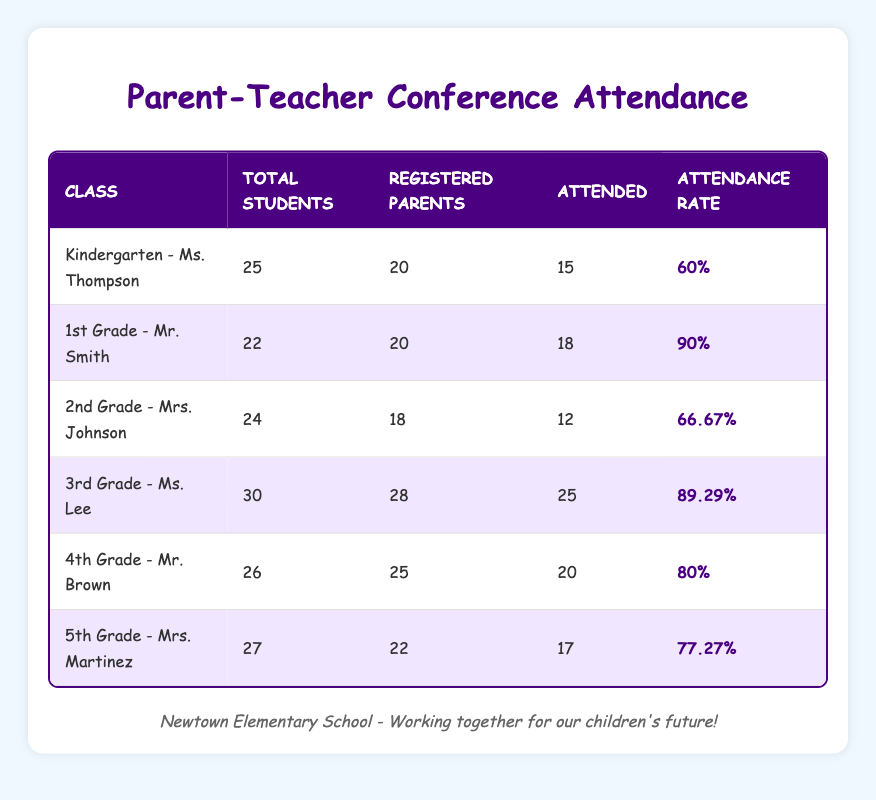What is the attendance rate for 5th Grade - Mrs. Martinez? In the table, find the row for 5th Grade - Mrs. Martinez, and locate the Attendance Rate column. The Attendance Rate listed is 77.27%.
Answer: 77.27% Which class had the highest attendance rate? To determine the class with the highest attendance rate, compare the Attendance Rate values from each class. 1st Grade - Mr. Smith has a rate of 90%, which is the highest.
Answer: 1st Grade - Mr. Smith How many registered parents attended the conference in 3rd Grade - Ms. Lee? Check the row for 3rd Grade - Ms. Lee and find the Attended column. The number of registered parents who attended is 25.
Answer: 25 What is the average attendance rate across all classes? To find the average attendance rate, sum all attendance rates: 60 + 90 + 66.67 + 89.29 + 80 + 77.27 = 463.23. Then, divide by the number of classes: 463.23/6 = 77.20.
Answer: 77.20% Did more registered parents attend the conference in Kindergarten - Ms. Thompson than in 2nd Grade - Mrs. Johnson? The number of parents who attended Kindergarten - Ms. Thompson is 15, while in 2nd Grade - Mrs. Johnson it is 12. Since 15 is greater than 12, the answer is yes.
Answer: Yes What is the total number of students across all classes? To find the total number of students, sum the Total Students from each class: 25 + 22 + 24 + 30 + 26 + 27 = 154.
Answer: 154 Which class had fewer attendances: 4th Grade - Mr. Brown or 2nd Grade - Mrs. Johnson? The number of attendances for 4th Grade - Mr. Brown is 20, while for 2nd Grade - Mrs. Johnson it is 12. Comparing these two numbers, 12 is fewer than 20, so 2nd Grade - Mrs. Johnson had fewer attendances.
Answer: 2nd Grade - Mrs. Johnson Is the attendance rate for 4th Grade - Mr. Brown greater than the attendance rate for 5th Grade - Mrs. Martinez? The attendance rate for 4th Grade - Mr. Brown is 80%, and for 5th Grade - Mrs. Martinez it is 77.27%. Since 80 is greater than 77.27, the answer is yes.
Answer: Yes 